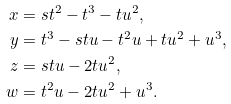<formula> <loc_0><loc_0><loc_500><loc_500>x & = { s } t ^ { 2 } - t ^ { 3 } - { t } u ^ { 2 } , \\ y & = t ^ { 3 } - { s } { t } { u } - t ^ { 2 } { u } + { t } u ^ { 2 } + u ^ { 3 } , \\ z & = { s } { t } { u } - 2 { t } u ^ { 2 } , \\ w & = t ^ { 2 } { u } - 2 { t } u ^ { 2 } + u ^ { 3 } .</formula> 